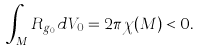Convert formula to latex. <formula><loc_0><loc_0><loc_500><loc_500>\int _ { M } R _ { g _ { 0 } } d V _ { 0 } = 2 \pi \chi ( M ) < 0 .</formula> 